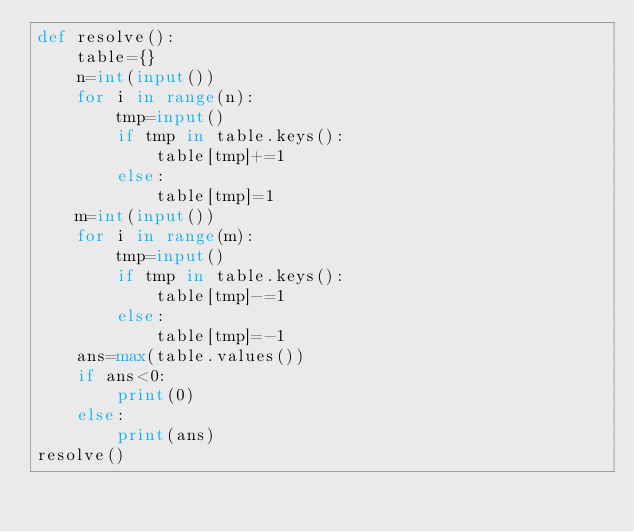<code> <loc_0><loc_0><loc_500><loc_500><_Python_>def resolve():
    table={}
    n=int(input())
    for i in range(n):
        tmp=input()
        if tmp in table.keys():
            table[tmp]+=1
        else:
            table[tmp]=1
    m=int(input())
    for i in range(m):
        tmp=input()
        if tmp in table.keys():
            table[tmp]-=1
        else:
            table[tmp]=-1
    ans=max(table.values())
    if ans<0:
        print(0)
    else:
        print(ans)
resolve()</code> 